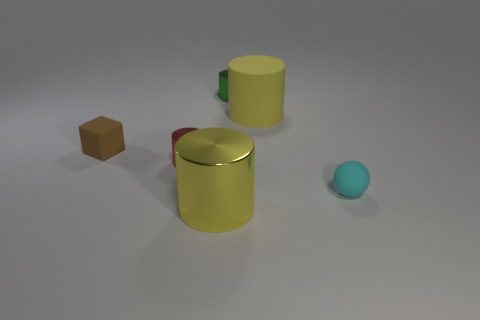What can you infer about the setting of this scene? This scene takes place in a controlled environment, likely an indoor studio setting that is designed for showcasing or testing objects. The neutral grey background assists in minimizing distractions, focusing attention on the objects themselves. Furthermore, the even and soft lighting suggests a setup aimed at preventing harsh shadows that could interfere with the perception of the materials' color and texture. What might be the purpose of arranging these objects together? Arranging these objects together can serve various purposes, such as for a comparative study of material properties in different lighting conditions, for creating a composition in a work of art, or for conducting physical simulations in a computer graphics environment. It could also be part of a product shoot where the items' designs and materials are being highlighted. 